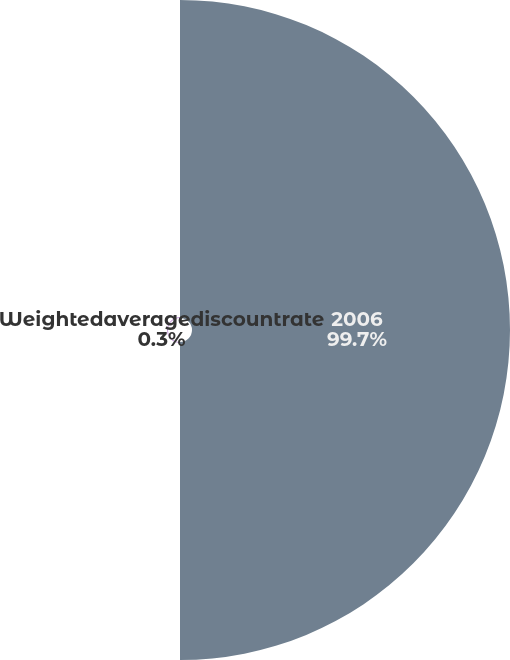<chart> <loc_0><loc_0><loc_500><loc_500><pie_chart><fcel>2006<fcel>Weightedaveragediscountrate<nl><fcel>99.7%<fcel>0.3%<nl></chart> 